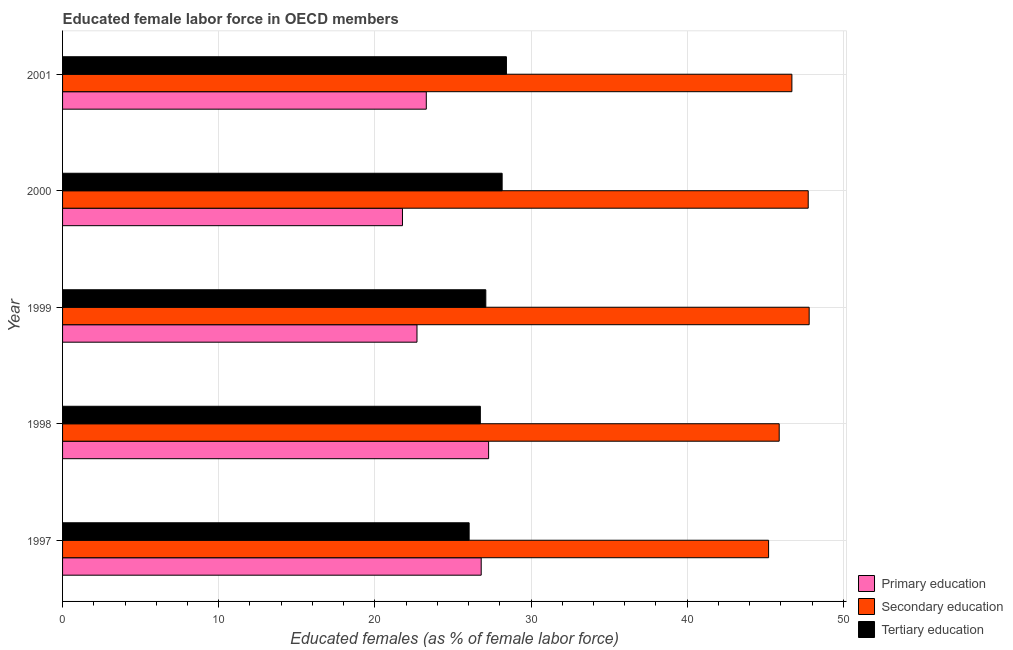Are the number of bars on each tick of the Y-axis equal?
Offer a very short reply. Yes. How many bars are there on the 5th tick from the bottom?
Ensure brevity in your answer.  3. What is the label of the 3rd group of bars from the top?
Your answer should be compact. 1999. What is the percentage of female labor force who received tertiary education in 1999?
Offer a very short reply. 27.1. Across all years, what is the maximum percentage of female labor force who received secondary education?
Your answer should be very brief. 47.81. Across all years, what is the minimum percentage of female labor force who received tertiary education?
Your response must be concise. 26.03. What is the total percentage of female labor force who received primary education in the graph?
Your answer should be compact. 121.84. What is the difference between the percentage of female labor force who received tertiary education in 1997 and that in 2001?
Your response must be concise. -2.39. What is the difference between the percentage of female labor force who received primary education in 1997 and the percentage of female labor force who received tertiary education in 2000?
Your answer should be very brief. -1.34. What is the average percentage of female labor force who received tertiary education per year?
Keep it short and to the point. 27.29. In the year 1998, what is the difference between the percentage of female labor force who received tertiary education and percentage of female labor force who received primary education?
Offer a very short reply. -0.53. In how many years, is the percentage of female labor force who received tertiary education greater than 2 %?
Your answer should be compact. 5. What is the ratio of the percentage of female labor force who received primary education in 1997 to that in 2001?
Offer a very short reply. 1.15. Is the percentage of female labor force who received tertiary education in 1997 less than that in 1998?
Your answer should be very brief. Yes. Is the difference between the percentage of female labor force who received primary education in 1997 and 1998 greater than the difference between the percentage of female labor force who received tertiary education in 1997 and 1998?
Make the answer very short. Yes. What is the difference between the highest and the second highest percentage of female labor force who received secondary education?
Provide a succinct answer. 0.06. What is the difference between the highest and the lowest percentage of female labor force who received secondary education?
Ensure brevity in your answer.  2.6. Is the sum of the percentage of female labor force who received tertiary education in 1997 and 1999 greater than the maximum percentage of female labor force who received secondary education across all years?
Keep it short and to the point. Yes. What does the 1st bar from the top in 1997 represents?
Offer a very short reply. Tertiary education. Is it the case that in every year, the sum of the percentage of female labor force who received primary education and percentage of female labor force who received secondary education is greater than the percentage of female labor force who received tertiary education?
Provide a succinct answer. Yes. How many bars are there?
Offer a very short reply. 15. Are all the bars in the graph horizontal?
Offer a very short reply. Yes. What is the difference between two consecutive major ticks on the X-axis?
Provide a short and direct response. 10. Are the values on the major ticks of X-axis written in scientific E-notation?
Keep it short and to the point. No. Does the graph contain any zero values?
Your answer should be very brief. No. How many legend labels are there?
Provide a short and direct response. 3. What is the title of the graph?
Give a very brief answer. Educated female labor force in OECD members. What is the label or title of the X-axis?
Provide a succinct answer. Educated females (as % of female labor force). What is the label or title of the Y-axis?
Give a very brief answer. Year. What is the Educated females (as % of female labor force) of Primary education in 1997?
Your response must be concise. 26.81. What is the Educated females (as % of female labor force) of Secondary education in 1997?
Provide a short and direct response. 45.21. What is the Educated females (as % of female labor force) in Tertiary education in 1997?
Your response must be concise. 26.03. What is the Educated females (as % of female labor force) of Primary education in 1998?
Keep it short and to the point. 27.28. What is the Educated females (as % of female labor force) of Secondary education in 1998?
Your answer should be very brief. 45.89. What is the Educated females (as % of female labor force) of Tertiary education in 1998?
Provide a succinct answer. 26.75. What is the Educated females (as % of female labor force) of Primary education in 1999?
Give a very brief answer. 22.7. What is the Educated females (as % of female labor force) in Secondary education in 1999?
Your answer should be very brief. 47.81. What is the Educated females (as % of female labor force) in Tertiary education in 1999?
Keep it short and to the point. 27.1. What is the Educated females (as % of female labor force) of Primary education in 2000?
Make the answer very short. 21.77. What is the Educated females (as % of female labor force) in Secondary education in 2000?
Offer a very short reply. 47.75. What is the Educated females (as % of female labor force) in Tertiary education in 2000?
Ensure brevity in your answer.  28.15. What is the Educated females (as % of female labor force) in Primary education in 2001?
Make the answer very short. 23.29. What is the Educated females (as % of female labor force) of Secondary education in 2001?
Ensure brevity in your answer.  46.7. What is the Educated females (as % of female labor force) of Tertiary education in 2001?
Provide a short and direct response. 28.42. Across all years, what is the maximum Educated females (as % of female labor force) of Primary education?
Provide a succinct answer. 27.28. Across all years, what is the maximum Educated females (as % of female labor force) in Secondary education?
Offer a terse response. 47.81. Across all years, what is the maximum Educated females (as % of female labor force) of Tertiary education?
Give a very brief answer. 28.42. Across all years, what is the minimum Educated females (as % of female labor force) in Primary education?
Ensure brevity in your answer.  21.77. Across all years, what is the minimum Educated females (as % of female labor force) in Secondary education?
Your answer should be compact. 45.21. Across all years, what is the minimum Educated females (as % of female labor force) in Tertiary education?
Give a very brief answer. 26.03. What is the total Educated females (as % of female labor force) of Primary education in the graph?
Your response must be concise. 121.84. What is the total Educated females (as % of female labor force) of Secondary education in the graph?
Your answer should be compact. 233.36. What is the total Educated females (as % of female labor force) of Tertiary education in the graph?
Your answer should be compact. 136.46. What is the difference between the Educated females (as % of female labor force) of Primary education in 1997 and that in 1998?
Your answer should be very brief. -0.47. What is the difference between the Educated females (as % of female labor force) of Secondary education in 1997 and that in 1998?
Your answer should be compact. -0.68. What is the difference between the Educated females (as % of female labor force) of Tertiary education in 1997 and that in 1998?
Your answer should be compact. -0.72. What is the difference between the Educated females (as % of female labor force) in Primary education in 1997 and that in 1999?
Offer a very short reply. 4.11. What is the difference between the Educated females (as % of female labor force) in Secondary education in 1997 and that in 1999?
Offer a very short reply. -2.6. What is the difference between the Educated females (as % of female labor force) of Tertiary education in 1997 and that in 1999?
Give a very brief answer. -1.07. What is the difference between the Educated females (as % of female labor force) in Primary education in 1997 and that in 2000?
Your response must be concise. 5.04. What is the difference between the Educated females (as % of female labor force) of Secondary education in 1997 and that in 2000?
Give a very brief answer. -2.54. What is the difference between the Educated females (as % of female labor force) of Tertiary education in 1997 and that in 2000?
Provide a succinct answer. -2.11. What is the difference between the Educated females (as % of female labor force) of Primary education in 1997 and that in 2001?
Offer a terse response. 3.52. What is the difference between the Educated females (as % of female labor force) of Secondary education in 1997 and that in 2001?
Ensure brevity in your answer.  -1.49. What is the difference between the Educated females (as % of female labor force) of Tertiary education in 1997 and that in 2001?
Keep it short and to the point. -2.39. What is the difference between the Educated females (as % of female labor force) in Primary education in 1998 and that in 1999?
Ensure brevity in your answer.  4.59. What is the difference between the Educated females (as % of female labor force) of Secondary education in 1998 and that in 1999?
Provide a short and direct response. -1.92. What is the difference between the Educated females (as % of female labor force) of Tertiary education in 1998 and that in 1999?
Provide a succinct answer. -0.35. What is the difference between the Educated females (as % of female labor force) of Primary education in 1998 and that in 2000?
Provide a short and direct response. 5.52. What is the difference between the Educated females (as % of female labor force) in Secondary education in 1998 and that in 2000?
Your response must be concise. -1.86. What is the difference between the Educated females (as % of female labor force) of Tertiary education in 1998 and that in 2000?
Your answer should be very brief. -1.4. What is the difference between the Educated females (as % of female labor force) of Primary education in 1998 and that in 2001?
Give a very brief answer. 3.99. What is the difference between the Educated females (as % of female labor force) in Secondary education in 1998 and that in 2001?
Your response must be concise. -0.81. What is the difference between the Educated females (as % of female labor force) of Tertiary education in 1998 and that in 2001?
Make the answer very short. -1.67. What is the difference between the Educated females (as % of female labor force) in Primary education in 1999 and that in 2000?
Provide a short and direct response. 0.93. What is the difference between the Educated females (as % of female labor force) in Secondary education in 1999 and that in 2000?
Provide a succinct answer. 0.06. What is the difference between the Educated females (as % of female labor force) in Tertiary education in 1999 and that in 2000?
Your answer should be compact. -1.05. What is the difference between the Educated females (as % of female labor force) of Primary education in 1999 and that in 2001?
Provide a succinct answer. -0.6. What is the difference between the Educated females (as % of female labor force) in Secondary education in 1999 and that in 2001?
Offer a terse response. 1.11. What is the difference between the Educated females (as % of female labor force) of Tertiary education in 1999 and that in 2001?
Offer a very short reply. -1.32. What is the difference between the Educated females (as % of female labor force) in Primary education in 2000 and that in 2001?
Your answer should be very brief. -1.53. What is the difference between the Educated females (as % of female labor force) of Secondary education in 2000 and that in 2001?
Offer a very short reply. 1.05. What is the difference between the Educated females (as % of female labor force) in Tertiary education in 2000 and that in 2001?
Make the answer very short. -0.28. What is the difference between the Educated females (as % of female labor force) in Primary education in 1997 and the Educated females (as % of female labor force) in Secondary education in 1998?
Give a very brief answer. -19.08. What is the difference between the Educated females (as % of female labor force) of Primary education in 1997 and the Educated females (as % of female labor force) of Tertiary education in 1998?
Offer a terse response. 0.06. What is the difference between the Educated females (as % of female labor force) in Secondary education in 1997 and the Educated females (as % of female labor force) in Tertiary education in 1998?
Your answer should be very brief. 18.46. What is the difference between the Educated females (as % of female labor force) in Primary education in 1997 and the Educated females (as % of female labor force) in Secondary education in 1999?
Offer a terse response. -21. What is the difference between the Educated females (as % of female labor force) in Primary education in 1997 and the Educated females (as % of female labor force) in Tertiary education in 1999?
Give a very brief answer. -0.29. What is the difference between the Educated females (as % of female labor force) of Secondary education in 1997 and the Educated females (as % of female labor force) of Tertiary education in 1999?
Offer a very short reply. 18.11. What is the difference between the Educated females (as % of female labor force) of Primary education in 1997 and the Educated females (as % of female labor force) of Secondary education in 2000?
Give a very brief answer. -20.94. What is the difference between the Educated females (as % of female labor force) in Primary education in 1997 and the Educated females (as % of female labor force) in Tertiary education in 2000?
Make the answer very short. -1.34. What is the difference between the Educated females (as % of female labor force) in Secondary education in 1997 and the Educated females (as % of female labor force) in Tertiary education in 2000?
Keep it short and to the point. 17.06. What is the difference between the Educated females (as % of female labor force) in Primary education in 1997 and the Educated females (as % of female labor force) in Secondary education in 2001?
Your answer should be compact. -19.89. What is the difference between the Educated females (as % of female labor force) in Primary education in 1997 and the Educated females (as % of female labor force) in Tertiary education in 2001?
Offer a terse response. -1.62. What is the difference between the Educated females (as % of female labor force) in Secondary education in 1997 and the Educated females (as % of female labor force) in Tertiary education in 2001?
Your response must be concise. 16.79. What is the difference between the Educated females (as % of female labor force) in Primary education in 1998 and the Educated females (as % of female labor force) in Secondary education in 1999?
Give a very brief answer. -20.53. What is the difference between the Educated females (as % of female labor force) in Primary education in 1998 and the Educated females (as % of female labor force) in Tertiary education in 1999?
Give a very brief answer. 0.18. What is the difference between the Educated females (as % of female labor force) of Secondary education in 1998 and the Educated females (as % of female labor force) of Tertiary education in 1999?
Provide a succinct answer. 18.79. What is the difference between the Educated females (as % of female labor force) of Primary education in 1998 and the Educated females (as % of female labor force) of Secondary education in 2000?
Ensure brevity in your answer.  -20.47. What is the difference between the Educated females (as % of female labor force) in Primary education in 1998 and the Educated females (as % of female labor force) in Tertiary education in 2000?
Keep it short and to the point. -0.87. What is the difference between the Educated females (as % of female labor force) in Secondary education in 1998 and the Educated females (as % of female labor force) in Tertiary education in 2000?
Offer a very short reply. 17.74. What is the difference between the Educated females (as % of female labor force) of Primary education in 1998 and the Educated females (as % of female labor force) of Secondary education in 2001?
Your response must be concise. -19.42. What is the difference between the Educated females (as % of female labor force) of Primary education in 1998 and the Educated females (as % of female labor force) of Tertiary education in 2001?
Ensure brevity in your answer.  -1.14. What is the difference between the Educated females (as % of female labor force) in Secondary education in 1998 and the Educated females (as % of female labor force) in Tertiary education in 2001?
Your answer should be compact. 17.47. What is the difference between the Educated females (as % of female labor force) of Primary education in 1999 and the Educated females (as % of female labor force) of Secondary education in 2000?
Your response must be concise. -25.05. What is the difference between the Educated females (as % of female labor force) in Primary education in 1999 and the Educated females (as % of female labor force) in Tertiary education in 2000?
Give a very brief answer. -5.45. What is the difference between the Educated females (as % of female labor force) in Secondary education in 1999 and the Educated females (as % of female labor force) in Tertiary education in 2000?
Offer a terse response. 19.66. What is the difference between the Educated females (as % of female labor force) of Primary education in 1999 and the Educated females (as % of female labor force) of Secondary education in 2001?
Your response must be concise. -24.01. What is the difference between the Educated females (as % of female labor force) in Primary education in 1999 and the Educated females (as % of female labor force) in Tertiary education in 2001?
Ensure brevity in your answer.  -5.73. What is the difference between the Educated females (as % of female labor force) of Secondary education in 1999 and the Educated females (as % of female labor force) of Tertiary education in 2001?
Provide a succinct answer. 19.39. What is the difference between the Educated females (as % of female labor force) in Primary education in 2000 and the Educated females (as % of female labor force) in Secondary education in 2001?
Offer a terse response. -24.94. What is the difference between the Educated females (as % of female labor force) in Primary education in 2000 and the Educated females (as % of female labor force) in Tertiary education in 2001?
Give a very brief answer. -6.66. What is the difference between the Educated females (as % of female labor force) in Secondary education in 2000 and the Educated females (as % of female labor force) in Tertiary education in 2001?
Your answer should be very brief. 19.32. What is the average Educated females (as % of female labor force) of Primary education per year?
Ensure brevity in your answer.  24.37. What is the average Educated females (as % of female labor force) in Secondary education per year?
Provide a short and direct response. 46.67. What is the average Educated females (as % of female labor force) of Tertiary education per year?
Offer a very short reply. 27.29. In the year 1997, what is the difference between the Educated females (as % of female labor force) of Primary education and Educated females (as % of female labor force) of Secondary education?
Give a very brief answer. -18.4. In the year 1997, what is the difference between the Educated females (as % of female labor force) in Primary education and Educated females (as % of female labor force) in Tertiary education?
Your answer should be very brief. 0.77. In the year 1997, what is the difference between the Educated females (as % of female labor force) of Secondary education and Educated females (as % of female labor force) of Tertiary education?
Give a very brief answer. 19.18. In the year 1998, what is the difference between the Educated females (as % of female labor force) of Primary education and Educated females (as % of female labor force) of Secondary education?
Offer a terse response. -18.61. In the year 1998, what is the difference between the Educated females (as % of female labor force) in Primary education and Educated females (as % of female labor force) in Tertiary education?
Keep it short and to the point. 0.53. In the year 1998, what is the difference between the Educated females (as % of female labor force) in Secondary education and Educated females (as % of female labor force) in Tertiary education?
Ensure brevity in your answer.  19.14. In the year 1999, what is the difference between the Educated females (as % of female labor force) in Primary education and Educated females (as % of female labor force) in Secondary education?
Offer a very short reply. -25.11. In the year 1999, what is the difference between the Educated females (as % of female labor force) in Primary education and Educated females (as % of female labor force) in Tertiary education?
Provide a succinct answer. -4.41. In the year 1999, what is the difference between the Educated females (as % of female labor force) in Secondary education and Educated females (as % of female labor force) in Tertiary education?
Your answer should be compact. 20.71. In the year 2000, what is the difference between the Educated females (as % of female labor force) in Primary education and Educated females (as % of female labor force) in Secondary education?
Make the answer very short. -25.98. In the year 2000, what is the difference between the Educated females (as % of female labor force) in Primary education and Educated females (as % of female labor force) in Tertiary education?
Give a very brief answer. -6.38. In the year 2000, what is the difference between the Educated females (as % of female labor force) of Secondary education and Educated females (as % of female labor force) of Tertiary education?
Make the answer very short. 19.6. In the year 2001, what is the difference between the Educated females (as % of female labor force) of Primary education and Educated females (as % of female labor force) of Secondary education?
Give a very brief answer. -23.41. In the year 2001, what is the difference between the Educated females (as % of female labor force) in Primary education and Educated females (as % of female labor force) in Tertiary education?
Offer a very short reply. -5.13. In the year 2001, what is the difference between the Educated females (as % of female labor force) in Secondary education and Educated females (as % of female labor force) in Tertiary education?
Make the answer very short. 18.28. What is the ratio of the Educated females (as % of female labor force) of Primary education in 1997 to that in 1998?
Offer a very short reply. 0.98. What is the ratio of the Educated females (as % of female labor force) of Secondary education in 1997 to that in 1998?
Make the answer very short. 0.99. What is the ratio of the Educated females (as % of female labor force) in Tertiary education in 1997 to that in 1998?
Keep it short and to the point. 0.97. What is the ratio of the Educated females (as % of female labor force) in Primary education in 1997 to that in 1999?
Your answer should be very brief. 1.18. What is the ratio of the Educated females (as % of female labor force) in Secondary education in 1997 to that in 1999?
Give a very brief answer. 0.95. What is the ratio of the Educated females (as % of female labor force) in Tertiary education in 1997 to that in 1999?
Your answer should be very brief. 0.96. What is the ratio of the Educated females (as % of female labor force) in Primary education in 1997 to that in 2000?
Your response must be concise. 1.23. What is the ratio of the Educated females (as % of female labor force) in Secondary education in 1997 to that in 2000?
Keep it short and to the point. 0.95. What is the ratio of the Educated females (as % of female labor force) in Tertiary education in 1997 to that in 2000?
Give a very brief answer. 0.92. What is the ratio of the Educated females (as % of female labor force) of Primary education in 1997 to that in 2001?
Offer a very short reply. 1.15. What is the ratio of the Educated females (as % of female labor force) of Secondary education in 1997 to that in 2001?
Make the answer very short. 0.97. What is the ratio of the Educated females (as % of female labor force) in Tertiary education in 1997 to that in 2001?
Make the answer very short. 0.92. What is the ratio of the Educated females (as % of female labor force) of Primary education in 1998 to that in 1999?
Your answer should be very brief. 1.2. What is the ratio of the Educated females (as % of female labor force) in Secondary education in 1998 to that in 1999?
Your answer should be very brief. 0.96. What is the ratio of the Educated females (as % of female labor force) in Tertiary education in 1998 to that in 1999?
Your answer should be compact. 0.99. What is the ratio of the Educated females (as % of female labor force) in Primary education in 1998 to that in 2000?
Offer a terse response. 1.25. What is the ratio of the Educated females (as % of female labor force) in Secondary education in 1998 to that in 2000?
Provide a succinct answer. 0.96. What is the ratio of the Educated females (as % of female labor force) of Tertiary education in 1998 to that in 2000?
Your answer should be very brief. 0.95. What is the ratio of the Educated females (as % of female labor force) of Primary education in 1998 to that in 2001?
Offer a terse response. 1.17. What is the ratio of the Educated females (as % of female labor force) in Secondary education in 1998 to that in 2001?
Ensure brevity in your answer.  0.98. What is the ratio of the Educated females (as % of female labor force) in Tertiary education in 1998 to that in 2001?
Your answer should be compact. 0.94. What is the ratio of the Educated females (as % of female labor force) in Primary education in 1999 to that in 2000?
Offer a very short reply. 1.04. What is the ratio of the Educated females (as % of female labor force) of Tertiary education in 1999 to that in 2000?
Offer a terse response. 0.96. What is the ratio of the Educated females (as % of female labor force) in Primary education in 1999 to that in 2001?
Provide a succinct answer. 0.97. What is the ratio of the Educated females (as % of female labor force) in Secondary education in 1999 to that in 2001?
Provide a succinct answer. 1.02. What is the ratio of the Educated females (as % of female labor force) of Tertiary education in 1999 to that in 2001?
Offer a terse response. 0.95. What is the ratio of the Educated females (as % of female labor force) in Primary education in 2000 to that in 2001?
Keep it short and to the point. 0.93. What is the ratio of the Educated females (as % of female labor force) in Secondary education in 2000 to that in 2001?
Offer a terse response. 1.02. What is the ratio of the Educated females (as % of female labor force) in Tertiary education in 2000 to that in 2001?
Your answer should be compact. 0.99. What is the difference between the highest and the second highest Educated females (as % of female labor force) in Primary education?
Keep it short and to the point. 0.47. What is the difference between the highest and the second highest Educated females (as % of female labor force) in Secondary education?
Give a very brief answer. 0.06. What is the difference between the highest and the second highest Educated females (as % of female labor force) of Tertiary education?
Give a very brief answer. 0.28. What is the difference between the highest and the lowest Educated females (as % of female labor force) of Primary education?
Your answer should be very brief. 5.52. What is the difference between the highest and the lowest Educated females (as % of female labor force) of Secondary education?
Your answer should be very brief. 2.6. What is the difference between the highest and the lowest Educated females (as % of female labor force) in Tertiary education?
Offer a very short reply. 2.39. 